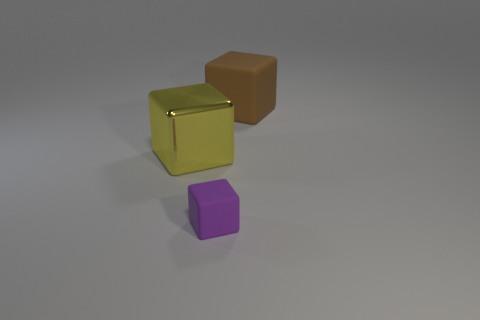What can you infer about the surface the objects are resting on? The objects are resting on a flat, smooth surface that looks like a matte ground. There's a subtle gradient suggesting slight illumination differences across the scene, possibly from the angle of the light source. The smoothness of the surface contributes to the softness of shadows cast by the objects. Does the surface have any texture or is it completely flat? It's difficult to discern any significant texture from this image; the surface appears quite flat and uniform. No visible imperfections or patterns suggest a simple, untextured material. 